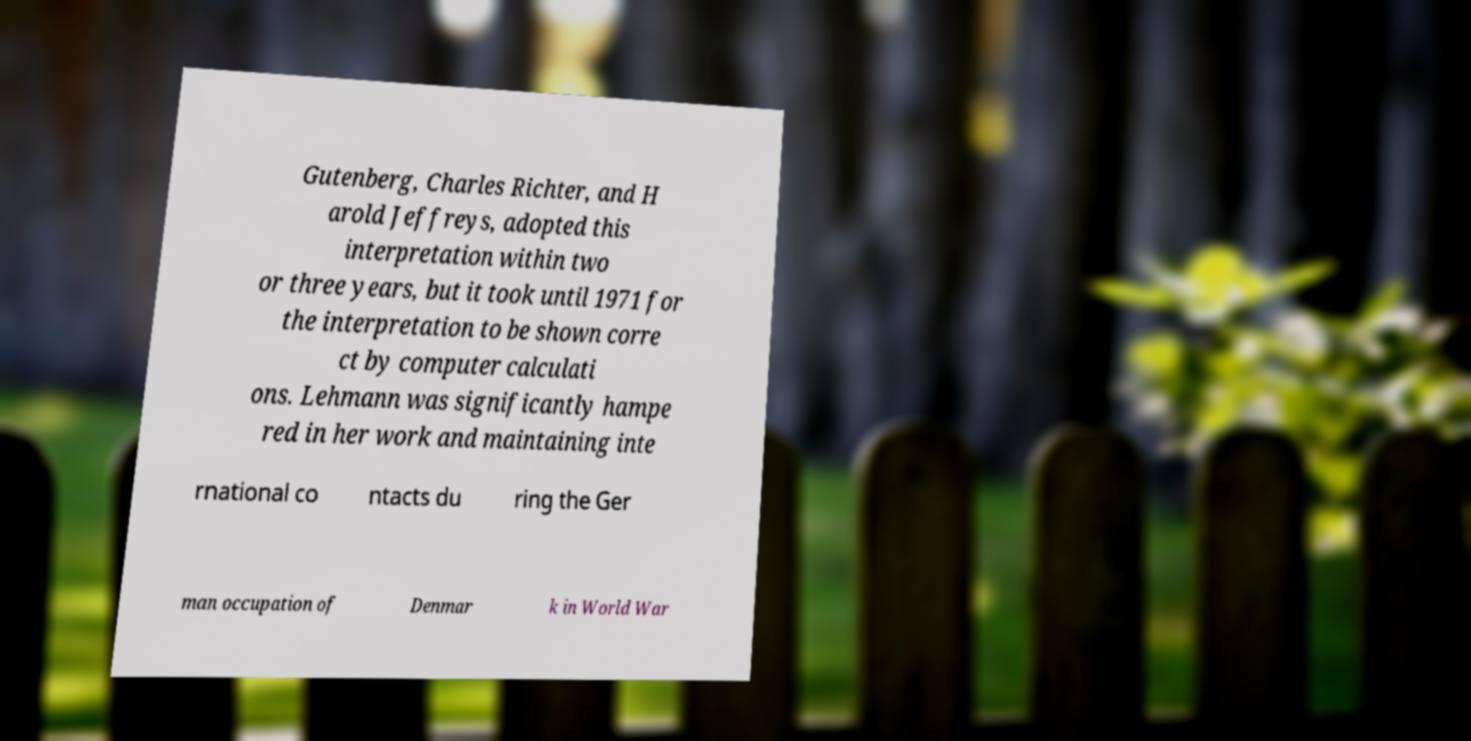Can you read and provide the text displayed in the image?This photo seems to have some interesting text. Can you extract and type it out for me? Gutenberg, Charles Richter, and H arold Jeffreys, adopted this interpretation within two or three years, but it took until 1971 for the interpretation to be shown corre ct by computer calculati ons. Lehmann was significantly hampe red in her work and maintaining inte rnational co ntacts du ring the Ger man occupation of Denmar k in World War 